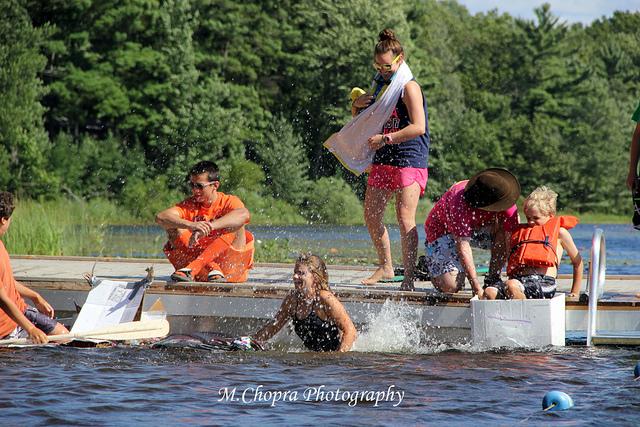Is there a ladder?
Write a very short answer. Yes. Who took the photo?
Write a very short answer. M chopra. Does everyone have on a life jacket?
Give a very brief answer. No. 